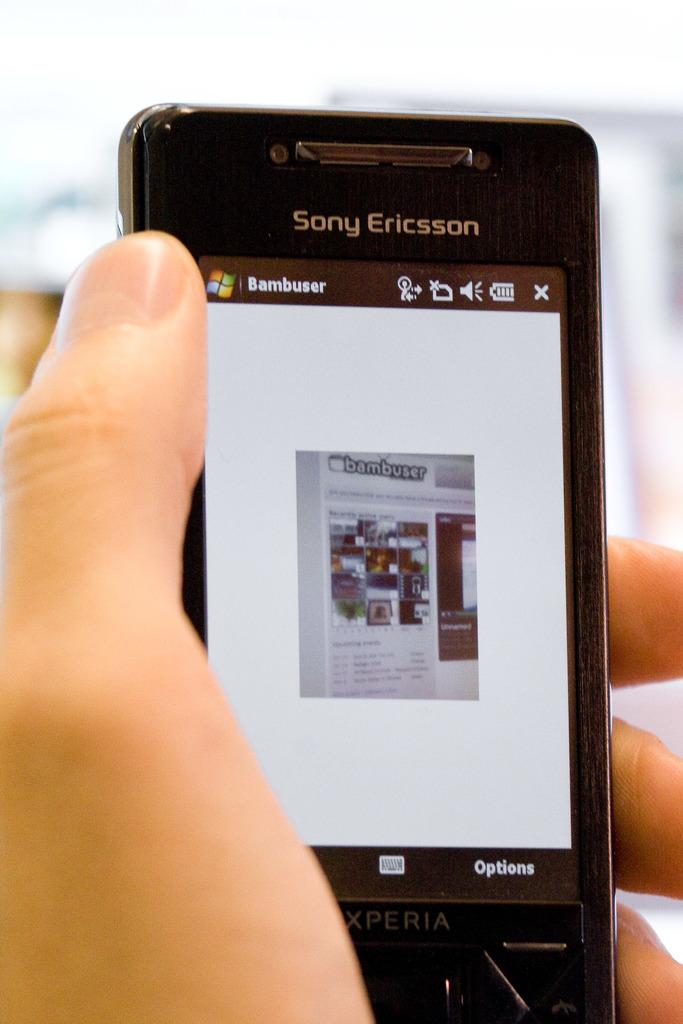Provide a one-sentence caption for the provided image. Black Sony Ericsson Xperia with a Bambuser logo. 